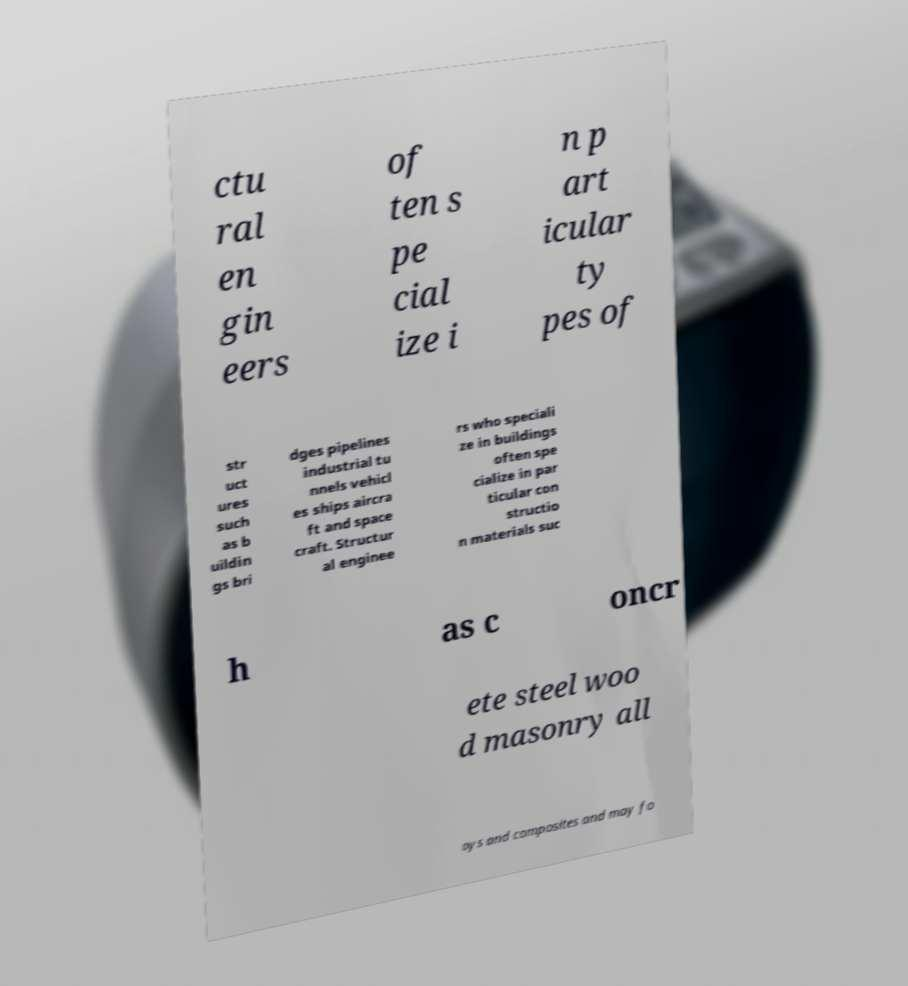Could you extract and type out the text from this image? ctu ral en gin eers of ten s pe cial ize i n p art icular ty pes of str uct ures such as b uildin gs bri dges pipelines industrial tu nnels vehicl es ships aircra ft and space craft. Structur al enginee rs who speciali ze in buildings often spe cialize in par ticular con structio n materials suc h as c oncr ete steel woo d masonry all oys and composites and may fo 